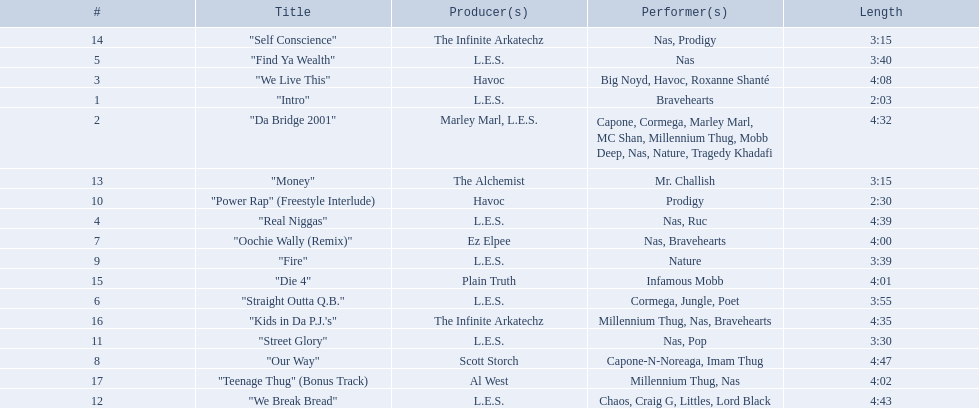What are all the songs on the album? "Intro", "Da Bridge 2001", "We Live This", "Real Niggas", "Find Ya Wealth", "Straight Outta Q.B.", "Oochie Wally (Remix)", "Our Way", "Fire", "Power Rap" (Freestyle Interlude), "Street Glory", "We Break Bread", "Money", "Self Conscience", "Die 4", "Kids in Da P.J.'s", "Teenage Thug" (Bonus Track). Would you be able to parse every entry in this table? {'header': ['#', 'Title', 'Producer(s)', 'Performer(s)', 'Length'], 'rows': [['14', '"Self Conscience"', 'The Infinite Arkatechz', 'Nas, Prodigy', '3:15'], ['5', '"Find Ya Wealth"', 'L.E.S.', 'Nas', '3:40'], ['3', '"We Live This"', 'Havoc', 'Big Noyd, Havoc, Roxanne Shanté', '4:08'], ['1', '"Intro"', 'L.E.S.', 'Bravehearts', '2:03'], ['2', '"Da Bridge 2001"', 'Marley Marl, L.E.S.', 'Capone, Cormega, Marley Marl, MC Shan, Millennium Thug, Mobb Deep, Nas, Nature, Tragedy Khadafi', '4:32'], ['13', '"Money"', 'The Alchemist', 'Mr. Challish', '3:15'], ['10', '"Power Rap" (Freestyle Interlude)', 'Havoc', 'Prodigy', '2:30'], ['4', '"Real Niggas"', 'L.E.S.', 'Nas, Ruc', '4:39'], ['7', '"Oochie Wally (Remix)"', 'Ez Elpee', 'Nas, Bravehearts', '4:00'], ['9', '"Fire"', 'L.E.S.', 'Nature', '3:39'], ['15', '"Die 4"', 'Plain Truth', 'Infamous Mobb', '4:01'], ['6', '"Straight Outta Q.B."', 'L.E.S.', 'Cormega, Jungle, Poet', '3:55'], ['16', '"Kids in Da P.J.\'s"', 'The Infinite Arkatechz', 'Millennium Thug, Nas, Bravehearts', '4:35'], ['11', '"Street Glory"', 'L.E.S.', 'Nas, Pop', '3:30'], ['8', '"Our Way"', 'Scott Storch', 'Capone-N-Noreaga, Imam Thug', '4:47'], ['17', '"Teenage Thug" (Bonus Track)', 'Al West', 'Millennium Thug, Nas', '4:02'], ['12', '"We Break Bread"', 'L.E.S.', 'Chaos, Craig G, Littles, Lord Black', '4:43']]} Which is the shortest? "Intro". How long is that song? 2:03. 